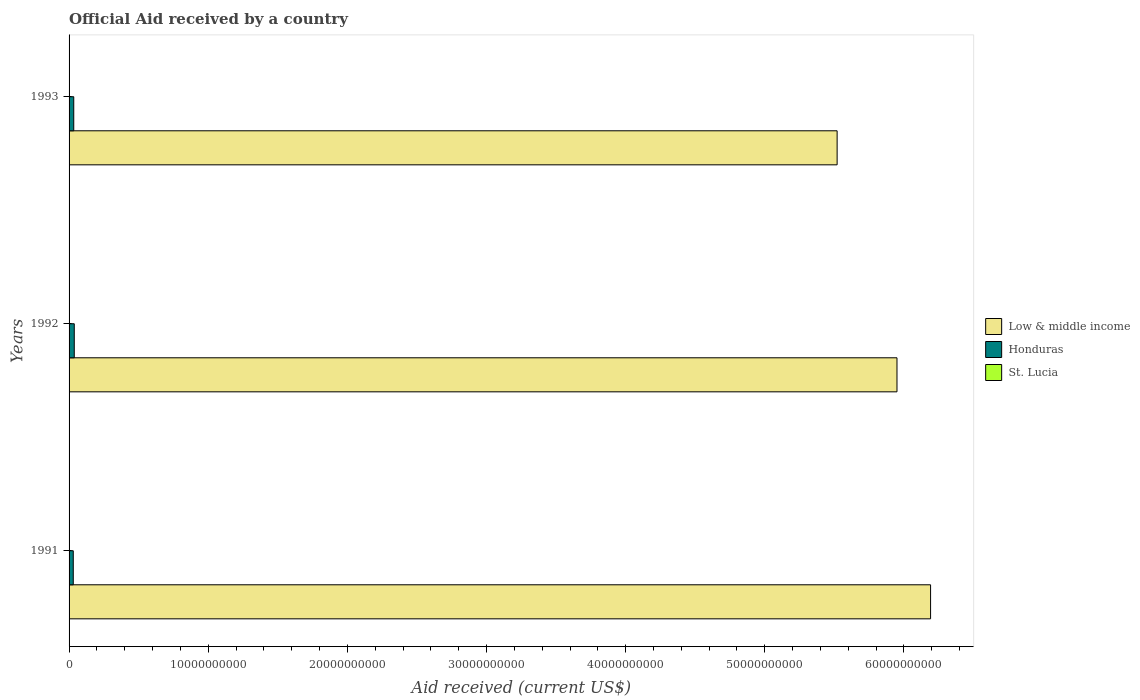How many groups of bars are there?
Your answer should be very brief. 3. How many bars are there on the 2nd tick from the bottom?
Give a very brief answer. 3. What is the label of the 1st group of bars from the top?
Provide a short and direct response. 1993. In how many cases, is the number of bars for a given year not equal to the number of legend labels?
Your response must be concise. 0. What is the net official aid received in Honduras in 1991?
Your response must be concise. 3.02e+08. Across all years, what is the maximum net official aid received in St. Lucia?
Provide a short and direct response. 2.71e+07. Across all years, what is the minimum net official aid received in Low & middle income?
Your response must be concise. 5.52e+1. In which year was the net official aid received in Low & middle income maximum?
Give a very brief answer. 1991. In which year was the net official aid received in Low & middle income minimum?
Give a very brief answer. 1993. What is the total net official aid received in Low & middle income in the graph?
Your answer should be very brief. 1.77e+11. What is the difference between the net official aid received in St. Lucia in 1991 and that in 1993?
Offer a very short reply. -2.51e+06. What is the difference between the net official aid received in St. Lucia in 1993 and the net official aid received in Honduras in 1991?
Give a very brief answer. -2.76e+08. What is the average net official aid received in Honduras per year?
Offer a terse response. 3.37e+08. In the year 1992, what is the difference between the net official aid received in Honduras and net official aid received in Low & middle income?
Offer a very short reply. -5.91e+1. What is the ratio of the net official aid received in Low & middle income in 1992 to that in 1993?
Your response must be concise. 1.08. Is the net official aid received in Low & middle income in 1992 less than that in 1993?
Offer a terse response. No. What is the difference between the highest and the second highest net official aid received in St. Lucia?
Give a very brief answer. 1.49e+06. What is the difference between the highest and the lowest net official aid received in Low & middle income?
Your answer should be very brief. 6.72e+09. What does the 2nd bar from the top in 1992 represents?
Your answer should be compact. Honduras. Is it the case that in every year, the sum of the net official aid received in Low & middle income and net official aid received in Honduras is greater than the net official aid received in St. Lucia?
Your answer should be compact. Yes. Does the graph contain any zero values?
Your answer should be very brief. No. Does the graph contain grids?
Offer a very short reply. No. Where does the legend appear in the graph?
Make the answer very short. Center right. How many legend labels are there?
Make the answer very short. 3. What is the title of the graph?
Offer a terse response. Official Aid received by a country. Does "Estonia" appear as one of the legend labels in the graph?
Your response must be concise. No. What is the label or title of the X-axis?
Your response must be concise. Aid received (current US$). What is the Aid received (current US$) of Low & middle income in 1991?
Provide a succinct answer. 6.19e+1. What is the Aid received (current US$) of Honduras in 1991?
Offer a very short reply. 3.02e+08. What is the Aid received (current US$) in St. Lucia in 1991?
Your response must be concise. 2.31e+07. What is the Aid received (current US$) of Low & middle income in 1992?
Offer a very short reply. 5.95e+1. What is the Aid received (current US$) in Honduras in 1992?
Your response must be concise. 3.73e+08. What is the Aid received (current US$) of St. Lucia in 1992?
Provide a short and direct response. 2.71e+07. What is the Aid received (current US$) in Low & middle income in 1993?
Provide a succinct answer. 5.52e+1. What is the Aid received (current US$) in Honduras in 1993?
Keep it short and to the point. 3.36e+08. What is the Aid received (current US$) of St. Lucia in 1993?
Your answer should be very brief. 2.56e+07. Across all years, what is the maximum Aid received (current US$) in Low & middle income?
Offer a very short reply. 6.19e+1. Across all years, what is the maximum Aid received (current US$) of Honduras?
Your answer should be compact. 3.73e+08. Across all years, what is the maximum Aid received (current US$) in St. Lucia?
Make the answer very short. 2.71e+07. Across all years, what is the minimum Aid received (current US$) in Low & middle income?
Keep it short and to the point. 5.52e+1. Across all years, what is the minimum Aid received (current US$) of Honduras?
Your response must be concise. 3.02e+08. Across all years, what is the minimum Aid received (current US$) of St. Lucia?
Offer a terse response. 2.31e+07. What is the total Aid received (current US$) in Low & middle income in the graph?
Provide a succinct answer. 1.77e+11. What is the total Aid received (current US$) in Honduras in the graph?
Keep it short and to the point. 1.01e+09. What is the total Aid received (current US$) in St. Lucia in the graph?
Ensure brevity in your answer.  7.59e+07. What is the difference between the Aid received (current US$) in Low & middle income in 1991 and that in 1992?
Offer a very short reply. 2.41e+09. What is the difference between the Aid received (current US$) of Honduras in 1991 and that in 1992?
Keep it short and to the point. -7.17e+07. What is the difference between the Aid received (current US$) in Low & middle income in 1991 and that in 1993?
Ensure brevity in your answer.  6.72e+09. What is the difference between the Aid received (current US$) of Honduras in 1991 and that in 1993?
Provide a short and direct response. -3.45e+07. What is the difference between the Aid received (current US$) in St. Lucia in 1991 and that in 1993?
Make the answer very short. -2.51e+06. What is the difference between the Aid received (current US$) of Low & middle income in 1992 and that in 1993?
Keep it short and to the point. 4.30e+09. What is the difference between the Aid received (current US$) of Honduras in 1992 and that in 1993?
Give a very brief answer. 3.72e+07. What is the difference between the Aid received (current US$) of St. Lucia in 1992 and that in 1993?
Your response must be concise. 1.49e+06. What is the difference between the Aid received (current US$) in Low & middle income in 1991 and the Aid received (current US$) in Honduras in 1992?
Your response must be concise. 6.15e+1. What is the difference between the Aid received (current US$) in Low & middle income in 1991 and the Aid received (current US$) in St. Lucia in 1992?
Provide a succinct answer. 6.19e+1. What is the difference between the Aid received (current US$) of Honduras in 1991 and the Aid received (current US$) of St. Lucia in 1992?
Make the answer very short. 2.75e+08. What is the difference between the Aid received (current US$) of Low & middle income in 1991 and the Aid received (current US$) of Honduras in 1993?
Ensure brevity in your answer.  6.16e+1. What is the difference between the Aid received (current US$) of Low & middle income in 1991 and the Aid received (current US$) of St. Lucia in 1993?
Your answer should be very brief. 6.19e+1. What is the difference between the Aid received (current US$) in Honduras in 1991 and the Aid received (current US$) in St. Lucia in 1993?
Offer a terse response. 2.76e+08. What is the difference between the Aid received (current US$) of Low & middle income in 1992 and the Aid received (current US$) of Honduras in 1993?
Provide a short and direct response. 5.92e+1. What is the difference between the Aid received (current US$) in Low & middle income in 1992 and the Aid received (current US$) in St. Lucia in 1993?
Keep it short and to the point. 5.95e+1. What is the difference between the Aid received (current US$) in Honduras in 1992 and the Aid received (current US$) in St. Lucia in 1993?
Offer a terse response. 3.48e+08. What is the average Aid received (current US$) of Low & middle income per year?
Make the answer very short. 5.89e+1. What is the average Aid received (current US$) of Honduras per year?
Offer a very short reply. 3.37e+08. What is the average Aid received (current US$) in St. Lucia per year?
Your answer should be very brief. 2.53e+07. In the year 1991, what is the difference between the Aid received (current US$) of Low & middle income and Aid received (current US$) of Honduras?
Your response must be concise. 6.16e+1. In the year 1991, what is the difference between the Aid received (current US$) of Low & middle income and Aid received (current US$) of St. Lucia?
Provide a short and direct response. 6.19e+1. In the year 1991, what is the difference between the Aid received (current US$) in Honduras and Aid received (current US$) in St. Lucia?
Ensure brevity in your answer.  2.79e+08. In the year 1992, what is the difference between the Aid received (current US$) of Low & middle income and Aid received (current US$) of Honduras?
Provide a short and direct response. 5.91e+1. In the year 1992, what is the difference between the Aid received (current US$) of Low & middle income and Aid received (current US$) of St. Lucia?
Your response must be concise. 5.95e+1. In the year 1992, what is the difference between the Aid received (current US$) in Honduras and Aid received (current US$) in St. Lucia?
Give a very brief answer. 3.46e+08. In the year 1993, what is the difference between the Aid received (current US$) in Low & middle income and Aid received (current US$) in Honduras?
Keep it short and to the point. 5.49e+1. In the year 1993, what is the difference between the Aid received (current US$) of Low & middle income and Aid received (current US$) of St. Lucia?
Make the answer very short. 5.52e+1. In the year 1993, what is the difference between the Aid received (current US$) of Honduras and Aid received (current US$) of St. Lucia?
Provide a short and direct response. 3.11e+08. What is the ratio of the Aid received (current US$) in Low & middle income in 1991 to that in 1992?
Offer a very short reply. 1.04. What is the ratio of the Aid received (current US$) in Honduras in 1991 to that in 1992?
Keep it short and to the point. 0.81. What is the ratio of the Aid received (current US$) in St. Lucia in 1991 to that in 1992?
Keep it short and to the point. 0.85. What is the ratio of the Aid received (current US$) in Low & middle income in 1991 to that in 1993?
Your answer should be compact. 1.12. What is the ratio of the Aid received (current US$) in Honduras in 1991 to that in 1993?
Ensure brevity in your answer.  0.9. What is the ratio of the Aid received (current US$) in St. Lucia in 1991 to that in 1993?
Your answer should be compact. 0.9. What is the ratio of the Aid received (current US$) in Low & middle income in 1992 to that in 1993?
Give a very brief answer. 1.08. What is the ratio of the Aid received (current US$) of Honduras in 1992 to that in 1993?
Give a very brief answer. 1.11. What is the ratio of the Aid received (current US$) in St. Lucia in 1992 to that in 1993?
Offer a terse response. 1.06. What is the difference between the highest and the second highest Aid received (current US$) in Low & middle income?
Your response must be concise. 2.41e+09. What is the difference between the highest and the second highest Aid received (current US$) in Honduras?
Your response must be concise. 3.72e+07. What is the difference between the highest and the second highest Aid received (current US$) in St. Lucia?
Your response must be concise. 1.49e+06. What is the difference between the highest and the lowest Aid received (current US$) of Low & middle income?
Provide a succinct answer. 6.72e+09. What is the difference between the highest and the lowest Aid received (current US$) of Honduras?
Give a very brief answer. 7.17e+07. What is the difference between the highest and the lowest Aid received (current US$) of St. Lucia?
Your response must be concise. 4.00e+06. 